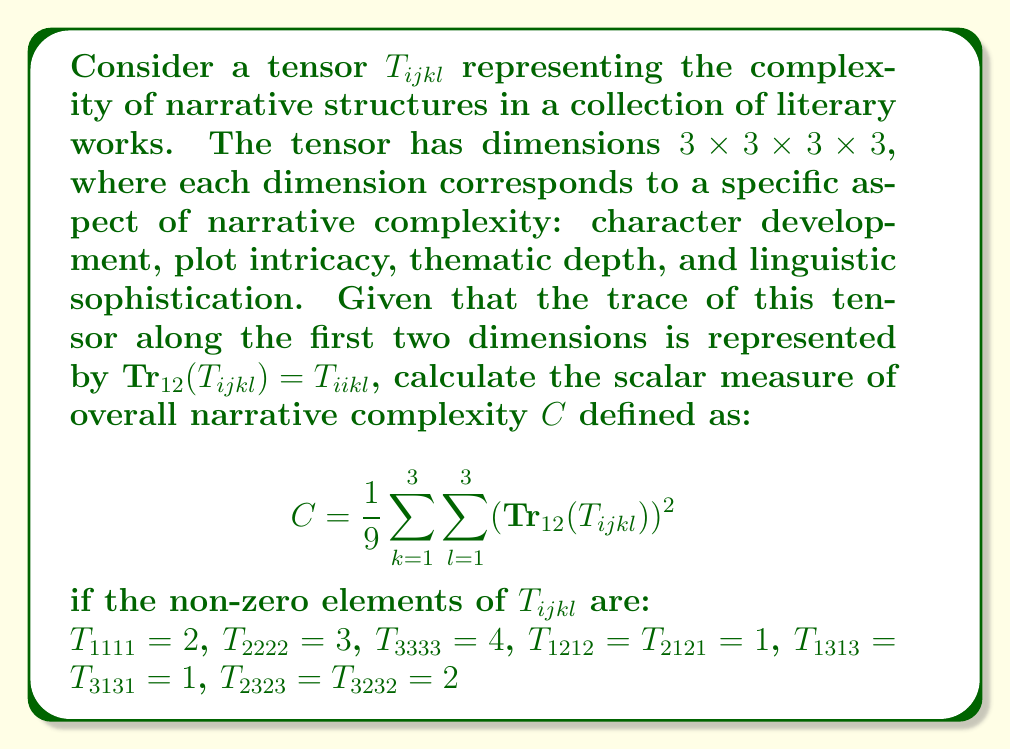Teach me how to tackle this problem. Let's approach this step-by-step:

1) First, we need to calculate $\text{Tr}_{12}(T_{ijkl})$. This trace is the sum of elements where the first two indices are equal:

   $\text{Tr}_{12}(T_{ijkl}) = T_{11kl} + T_{22kl} + T_{33kl}$

2) From the given non-zero elements, we can see that:
   
   $T_{1111} = 2$, $T_{2222} = 3$, $T_{3333} = 4$

   All other elements where $i=j$ and $k=l$ are zero.

3) Therefore, $\text{Tr}_{12}(T_{ijkl})$ is non-zero only when $k=l$:

   $\text{Tr}_{12}(T_{ij11}) = 2$
   $\text{Tr}_{12}(T_{ij22}) = 3$
   $\text{Tr}_{12}(T_{ij33}) = 4$

4) Now, let's calculate the sum in the formula for $C$:

   $$\sum_{k=1}^3 \sum_{l=1}^3 (\text{Tr}_{12}(T_{ijkl}))^2 = (2)^2 + (3)^2 + (4)^2 = 4 + 9 + 16 = 29$$

5) Finally, we can calculate $C$:

   $$C = \frac{1}{9} \sum_{k=1}^3 \sum_{l=1}^3 (\text{Tr}_{12}(T_{ijkl}))^2 = \frac{1}{9} \cdot 29 = \frac{29}{9}$$

Thus, the scalar measure of overall narrative complexity is $\frac{29}{9}$.
Answer: $\frac{29}{9}$ 